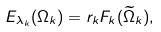<formula> <loc_0><loc_0><loc_500><loc_500>E _ { \lambda _ { k } } ( \Omega _ { k } ) = r _ { k } F _ { k } ( \widetilde { \Omega } _ { k } ) ,</formula> 